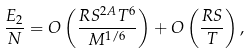<formula> <loc_0><loc_0><loc_500><loc_500>\frac { E _ { 2 } } { N } = O \left ( \frac { R S ^ { 2 A } T ^ { 6 } } { M ^ { 1 / 6 } } \right ) + O \left ( \frac { R S } { T } \right ) ,</formula> 